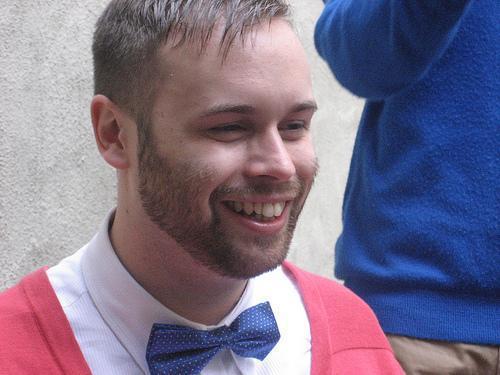How many ties are shown?
Give a very brief answer. 1. 